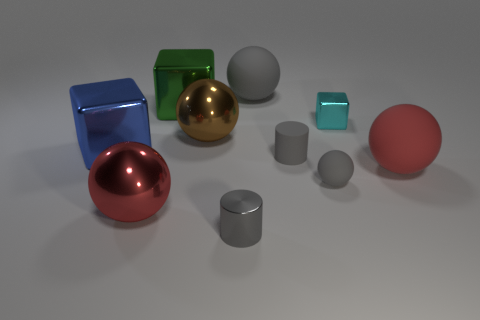Subtract all tiny blocks. How many blocks are left? 2 Subtract all green blocks. How many blocks are left? 2 Subtract all cylinders. How many objects are left? 8 Subtract all gray shiny things. Subtract all tiny gray shiny cylinders. How many objects are left? 8 Add 1 big gray matte spheres. How many big gray matte spheres are left? 2 Add 3 blocks. How many blocks exist? 6 Subtract 0 yellow cylinders. How many objects are left? 10 Subtract 2 blocks. How many blocks are left? 1 Subtract all brown blocks. Subtract all blue cylinders. How many blocks are left? 3 Subtract all purple cylinders. How many yellow spheres are left? 0 